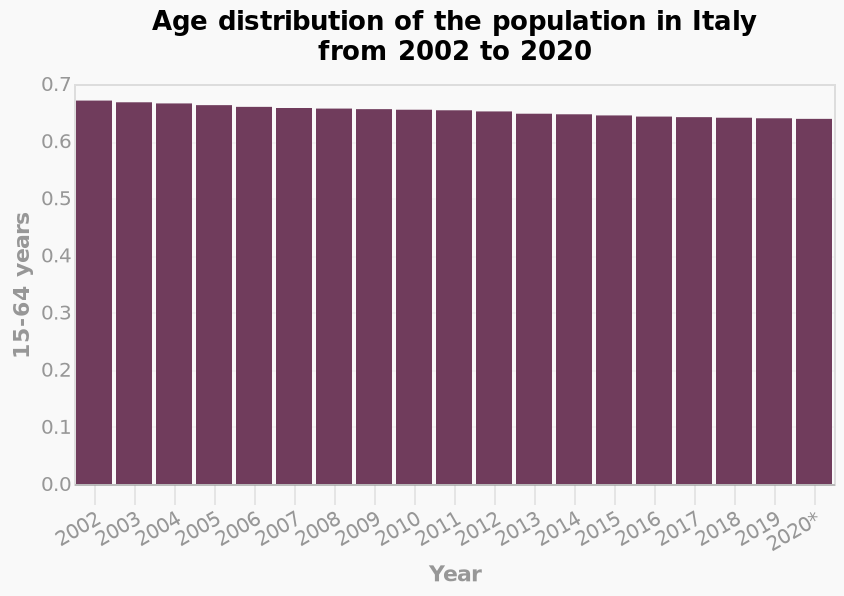<image>
Has the age distribution of the population increased or decreased from 2002 to 2020? The age distribution of the population has decreased slightly from 2002 to 2020. Has there been any significant change in the age distribution of the population from 2002 to 2020? No, there has been only a slight steady decrease in the age distribution of the population during that period. 